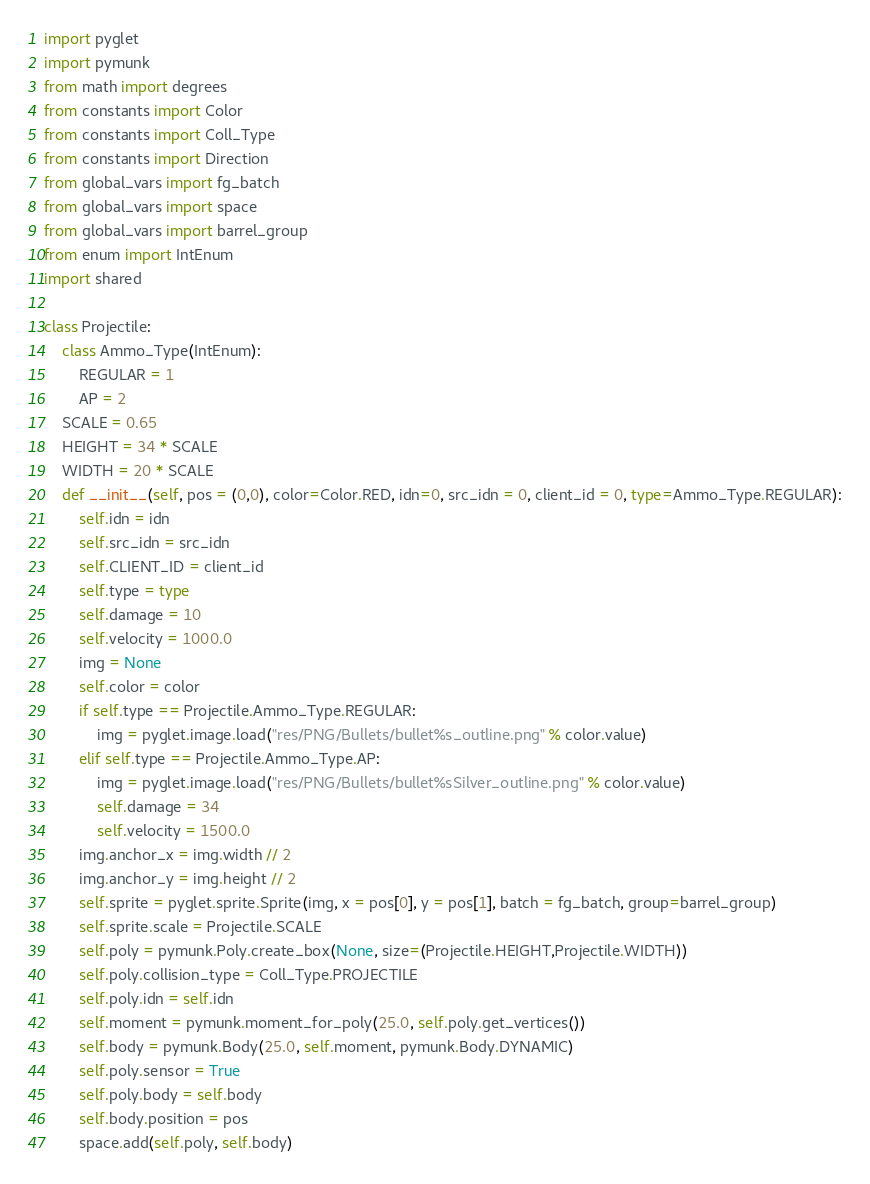Convert code to text. <code><loc_0><loc_0><loc_500><loc_500><_Python_>import pyglet
import pymunk
from math import degrees
from constants import Color
from constants import Coll_Type
from constants import Direction
from global_vars import fg_batch
from global_vars import space
from global_vars import barrel_group
from enum import IntEnum
import shared

class Projectile:
    class Ammo_Type(IntEnum):
        REGULAR = 1
        AP = 2
    SCALE = 0.65
    HEIGHT = 34 * SCALE
    WIDTH = 20 * SCALE
    def __init__(self, pos = (0,0), color=Color.RED, idn=0, src_idn = 0, client_id = 0, type=Ammo_Type.REGULAR):
        self.idn = idn
        self.src_idn = src_idn
        self.CLIENT_ID = client_id
        self.type = type
        self.damage = 10
        self.velocity = 1000.0
        img = None
        self.color = color
        if self.type == Projectile.Ammo_Type.REGULAR:
            img = pyglet.image.load("res/PNG/Bullets/bullet%s_outline.png" % color.value)
        elif self.type == Projectile.Ammo_Type.AP:
            img = pyglet.image.load("res/PNG/Bullets/bullet%sSilver_outline.png" % color.value)
            self.damage = 34
            self.velocity = 1500.0
        img.anchor_x = img.width // 2 
        img.anchor_y = img.height // 2 
        self.sprite = pyglet.sprite.Sprite(img, x = pos[0], y = pos[1], batch = fg_batch, group=barrel_group)
        self.sprite.scale = Projectile.SCALE
        self.poly = pymunk.Poly.create_box(None, size=(Projectile.HEIGHT,Projectile.WIDTH))
        self.poly.collision_type = Coll_Type.PROJECTILE
        self.poly.idn = self.idn
        self.moment = pymunk.moment_for_poly(25.0, self.poly.get_vertices())
        self.body = pymunk.Body(25.0, self.moment, pymunk.Body.DYNAMIC)
        self.poly.sensor = True
        self.poly.body = self.body
        self.body.position = pos
        space.add(self.poly, self.body)
</code> 